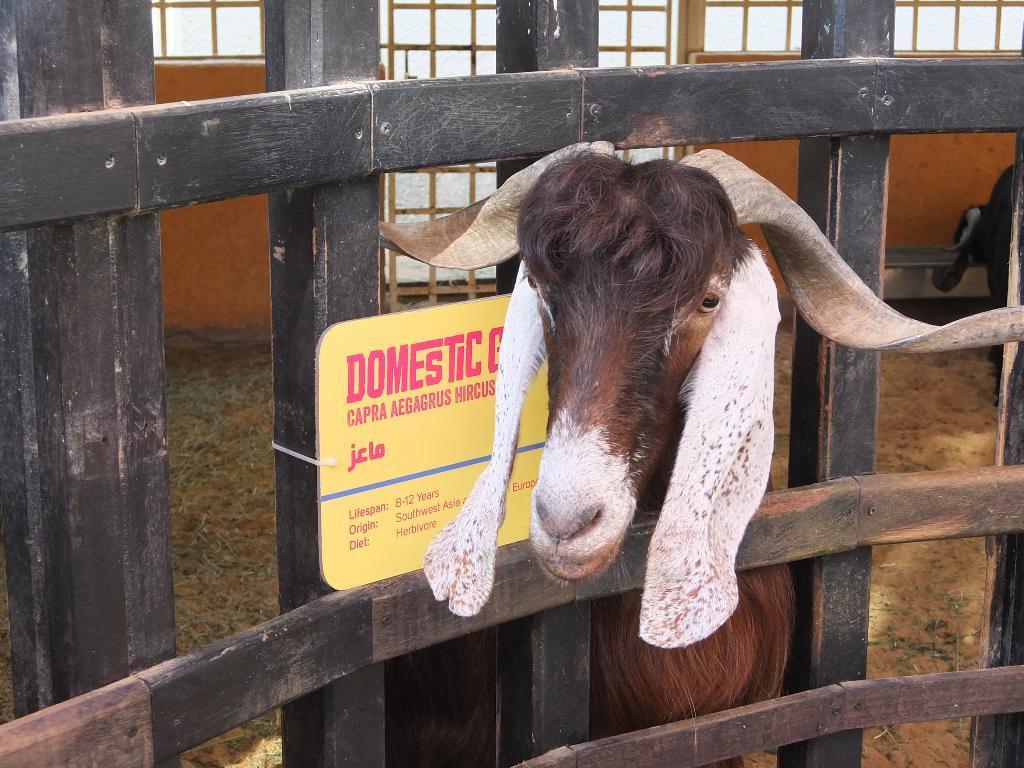In one or two sentences, can you explain what this image depicts? In this image we can see a goat, board, fence and in the background we can see the windows. 